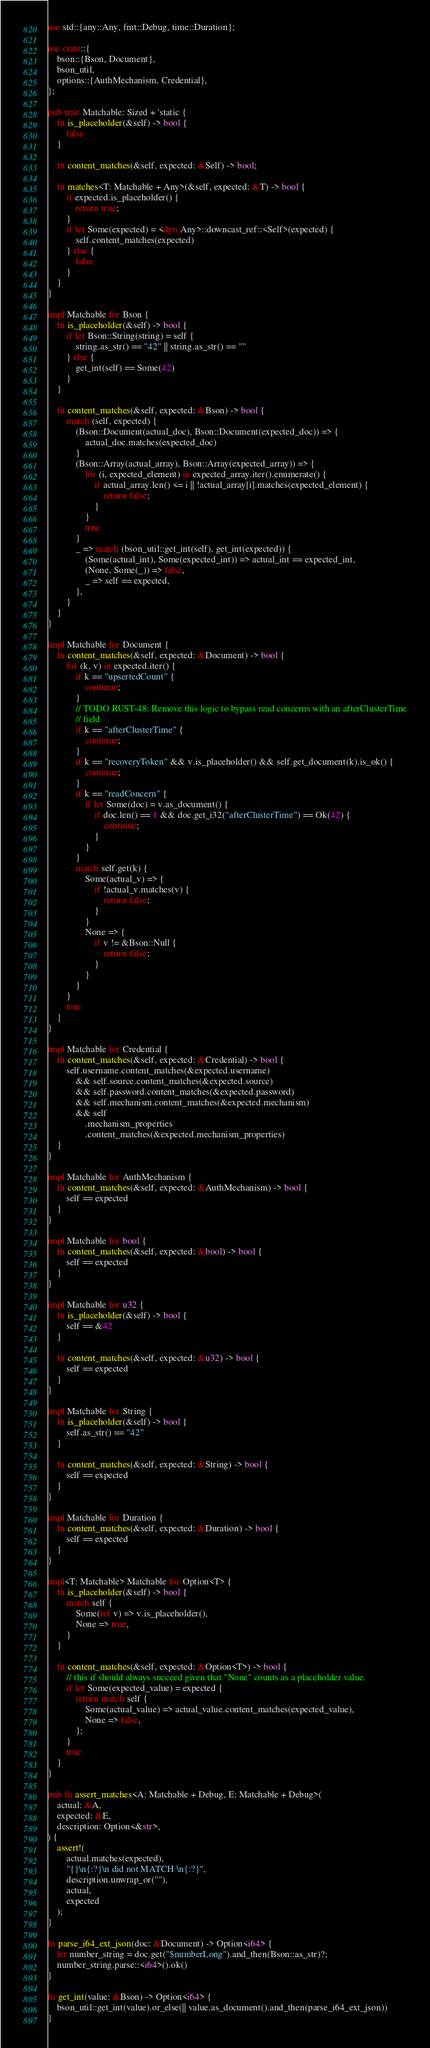Convert code to text. <code><loc_0><loc_0><loc_500><loc_500><_Rust_>use std::{any::Any, fmt::Debug, time::Duration};

use crate::{
    bson::{Bson, Document},
    bson_util,
    options::{AuthMechanism, Credential},
};

pub trait Matchable: Sized + 'static {
    fn is_placeholder(&self) -> bool {
        false
    }

    fn content_matches(&self, expected: &Self) -> bool;

    fn matches<T: Matchable + Any>(&self, expected: &T) -> bool {
        if expected.is_placeholder() {
            return true;
        }
        if let Some(expected) = <dyn Any>::downcast_ref::<Self>(expected) {
            self.content_matches(expected)
        } else {
            false
        }
    }
}

impl Matchable for Bson {
    fn is_placeholder(&self) -> bool {
        if let Bson::String(string) = self {
            string.as_str() == "42" || string.as_str() == ""
        } else {
            get_int(self) == Some(42)
        }
    }

    fn content_matches(&self, expected: &Bson) -> bool {
        match (self, expected) {
            (Bson::Document(actual_doc), Bson::Document(expected_doc)) => {
                actual_doc.matches(expected_doc)
            }
            (Bson::Array(actual_array), Bson::Array(expected_array)) => {
                for (i, expected_element) in expected_array.iter().enumerate() {
                    if actual_array.len() <= i || !actual_array[i].matches(expected_element) {
                        return false;
                    }
                }
                true
            }
            _ => match (bson_util::get_int(self), get_int(expected)) {
                (Some(actual_int), Some(expected_int)) => actual_int == expected_int,
                (None, Some(_)) => false,
                _ => self == expected,
            },
        }
    }
}

impl Matchable for Document {
    fn content_matches(&self, expected: &Document) -> bool {
        for (k, v) in expected.iter() {
            if k == "upsertedCount" {
                continue;
            }
            // TODO RUST-48: Remove this logic to bypass read concerns with an afterClusterTime
            // field
            if k == "afterClusterTime" {
                continue;
            }
            if k == "recoveryToken" && v.is_placeholder() && self.get_document(k).is_ok() {
                continue;
            }
            if k == "readConcern" {
                if let Some(doc) = v.as_document() {
                    if doc.len() == 1 && doc.get_i32("afterClusterTime") == Ok(42) {
                        continue;
                    }
                }
            }
            match self.get(k) {
                Some(actual_v) => {
                    if !actual_v.matches(v) {
                        return false;
                    }
                }
                None => {
                    if v != &Bson::Null {
                        return false;
                    }
                }
            }
        }
        true
    }
}

impl Matchable for Credential {
    fn content_matches(&self, expected: &Credential) -> bool {
        self.username.content_matches(&expected.username)
            && self.source.content_matches(&expected.source)
            && self.password.content_matches(&expected.password)
            && self.mechanism.content_matches(&expected.mechanism)
            && self
                .mechanism_properties
                .content_matches(&expected.mechanism_properties)
    }
}

impl Matchable for AuthMechanism {
    fn content_matches(&self, expected: &AuthMechanism) -> bool {
        self == expected
    }
}

impl Matchable for bool {
    fn content_matches(&self, expected: &bool) -> bool {
        self == expected
    }
}

impl Matchable for u32 {
    fn is_placeholder(&self) -> bool {
        self == &42
    }

    fn content_matches(&self, expected: &u32) -> bool {
        self == expected
    }
}

impl Matchable for String {
    fn is_placeholder(&self) -> bool {
        self.as_str() == "42"
    }

    fn content_matches(&self, expected: &String) -> bool {
        self == expected
    }
}

impl Matchable for Duration {
    fn content_matches(&self, expected: &Duration) -> bool {
        self == expected
    }
}

impl<T: Matchable> Matchable for Option<T> {
    fn is_placeholder(&self) -> bool {
        match self {
            Some(ref v) => v.is_placeholder(),
            None => true,
        }
    }

    fn content_matches(&self, expected: &Option<T>) -> bool {
        // this if should always succeed given that "None" counts as a placeholder value.
        if let Some(expected_value) = expected {
            return match self {
                Some(actual_value) => actual_value.content_matches(expected_value),
                None => false,
            };
        }
        true
    }
}

pub fn assert_matches<A: Matchable + Debug, E: Matchable + Debug>(
    actual: &A,
    expected: &E,
    description: Option<&str>,
) {
    assert!(
        actual.matches(expected),
        "{}\n{:?}\n did not MATCH \n{:?}",
        description.unwrap_or(""),
        actual,
        expected
    );
}

fn parse_i64_ext_json(doc: &Document) -> Option<i64> {
    let number_string = doc.get("$numberLong").and_then(Bson::as_str)?;
    number_string.parse::<i64>().ok()
}

fn get_int(value: &Bson) -> Option<i64> {
    bson_util::get_int(value).or_else(|| value.as_document().and_then(parse_i64_ext_json))
}
</code> 